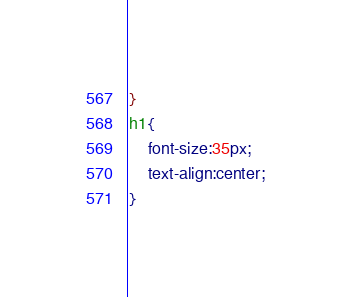Convert code to text. <code><loc_0><loc_0><loc_500><loc_500><_CSS_>
}
h1{
	font-size:35px;
	text-align:center;
}</code> 